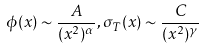<formula> <loc_0><loc_0><loc_500><loc_500>\phi ( x ) \sim \frac { A } { ( x ^ { 2 } ) ^ { \alpha } } , \sigma _ { T } ( x ) \sim \frac { C } { ( x ^ { 2 } ) ^ { \gamma } }</formula> 